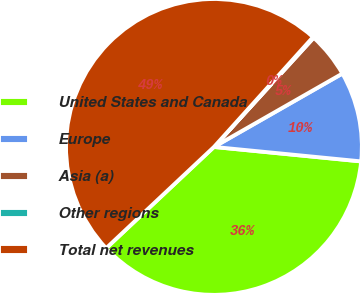Convert chart. <chart><loc_0><loc_0><loc_500><loc_500><pie_chart><fcel>United States and Canada<fcel>Europe<fcel>Asia (a)<fcel>Other regions<fcel>Total net revenues<nl><fcel>36.44%<fcel>9.82%<fcel>4.96%<fcel>0.1%<fcel>48.68%<nl></chart> 